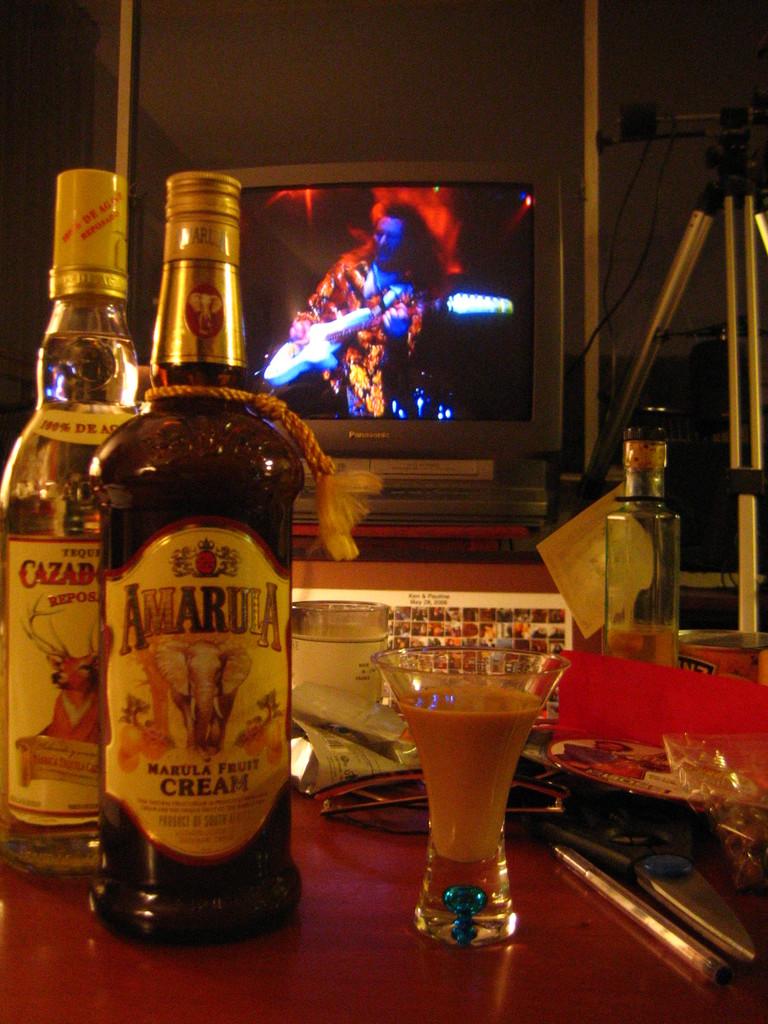What brand is the bottle in the front?
Your answer should be compact. Amarula. 